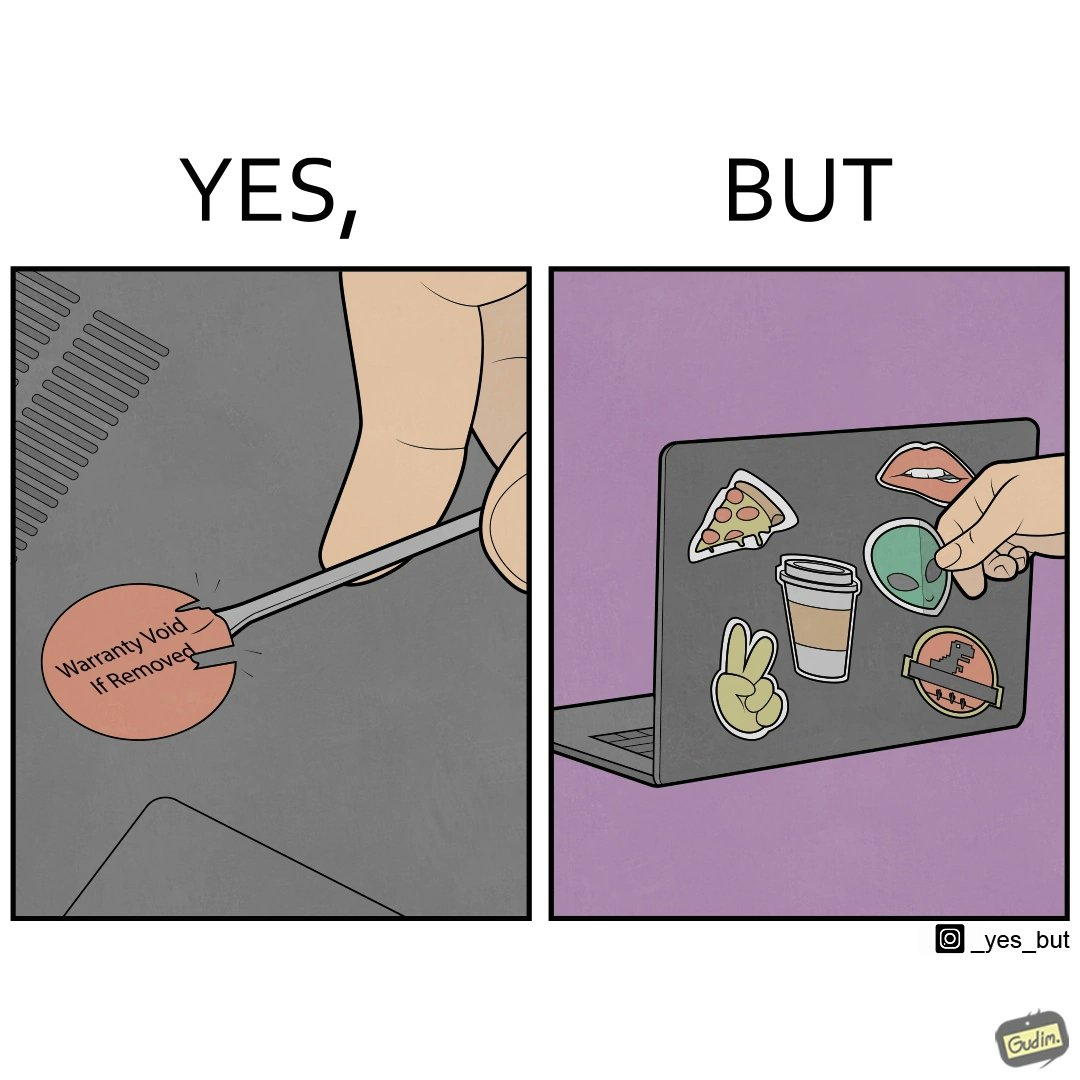Is there satirical content in this image? Yes, this image is satirical. 